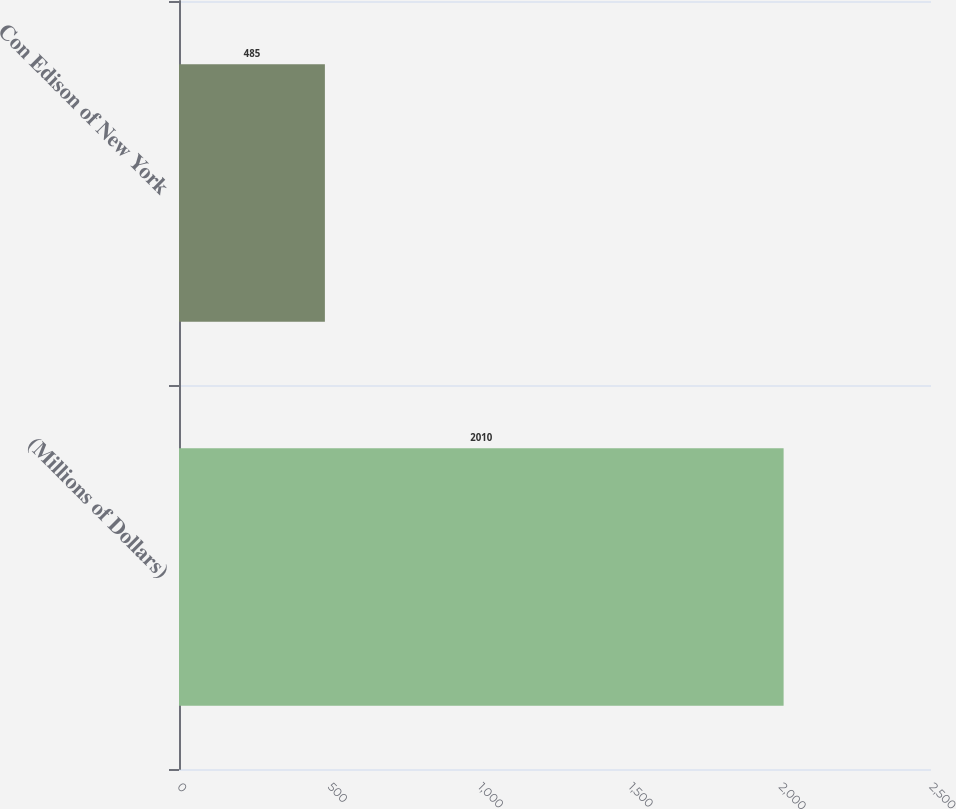Convert chart to OTSL. <chart><loc_0><loc_0><loc_500><loc_500><bar_chart><fcel>(Millions of Dollars)<fcel>Con Edison of New York<nl><fcel>2010<fcel>485<nl></chart> 